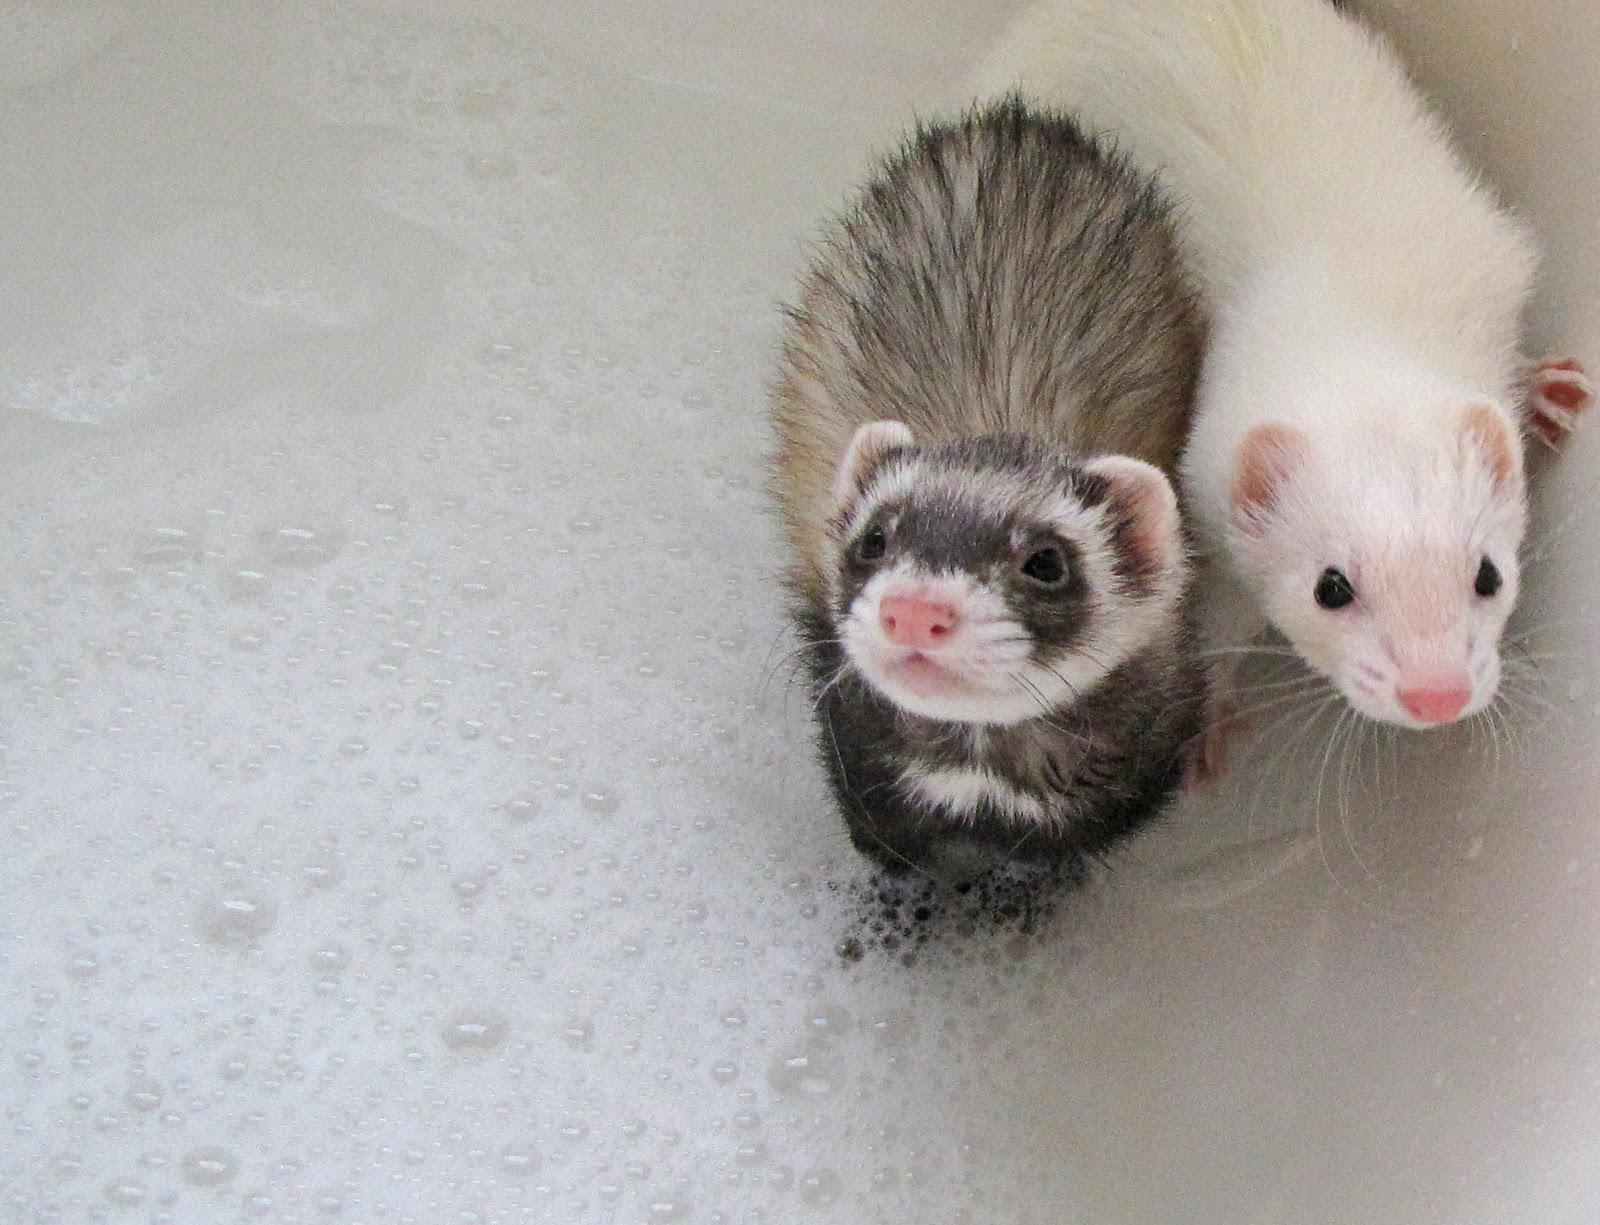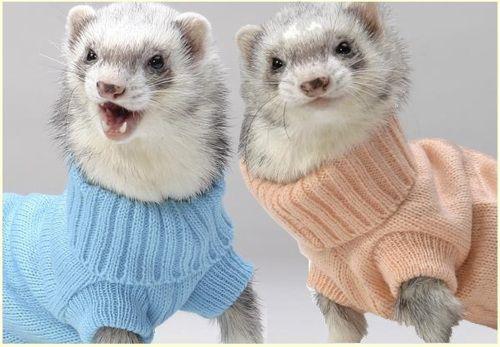The first image is the image on the left, the second image is the image on the right. Considering the images on both sides, is "At least one guinea pig is cleaning another's face." valid? Answer yes or no. No. The first image is the image on the left, the second image is the image on the right. Analyze the images presented: Is the assertion "a pair of ferrets are next to each other on top of draped fabric" valid? Answer yes or no. No. 